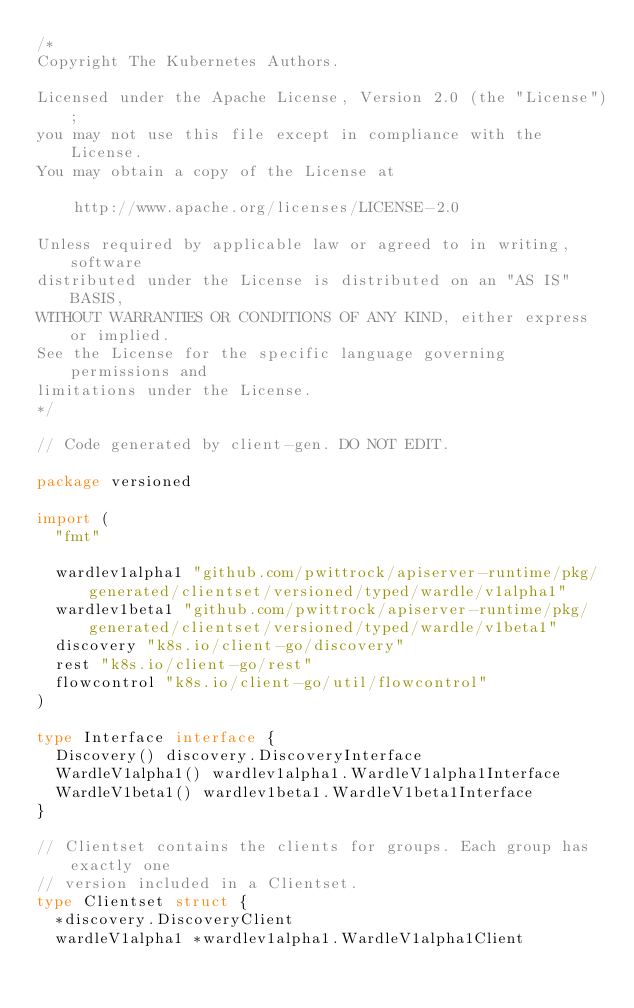Convert code to text. <code><loc_0><loc_0><loc_500><loc_500><_Go_>/*
Copyright The Kubernetes Authors.

Licensed under the Apache License, Version 2.0 (the "License");
you may not use this file except in compliance with the License.
You may obtain a copy of the License at

    http://www.apache.org/licenses/LICENSE-2.0

Unless required by applicable law or agreed to in writing, software
distributed under the License is distributed on an "AS IS" BASIS,
WITHOUT WARRANTIES OR CONDITIONS OF ANY KIND, either express or implied.
See the License for the specific language governing permissions and
limitations under the License.
*/

// Code generated by client-gen. DO NOT EDIT.

package versioned

import (
	"fmt"

	wardlev1alpha1 "github.com/pwittrock/apiserver-runtime/pkg/generated/clientset/versioned/typed/wardle/v1alpha1"
	wardlev1beta1 "github.com/pwittrock/apiserver-runtime/pkg/generated/clientset/versioned/typed/wardle/v1beta1"
	discovery "k8s.io/client-go/discovery"
	rest "k8s.io/client-go/rest"
	flowcontrol "k8s.io/client-go/util/flowcontrol"
)

type Interface interface {
	Discovery() discovery.DiscoveryInterface
	WardleV1alpha1() wardlev1alpha1.WardleV1alpha1Interface
	WardleV1beta1() wardlev1beta1.WardleV1beta1Interface
}

// Clientset contains the clients for groups. Each group has exactly one
// version included in a Clientset.
type Clientset struct {
	*discovery.DiscoveryClient
	wardleV1alpha1 *wardlev1alpha1.WardleV1alpha1Client</code> 